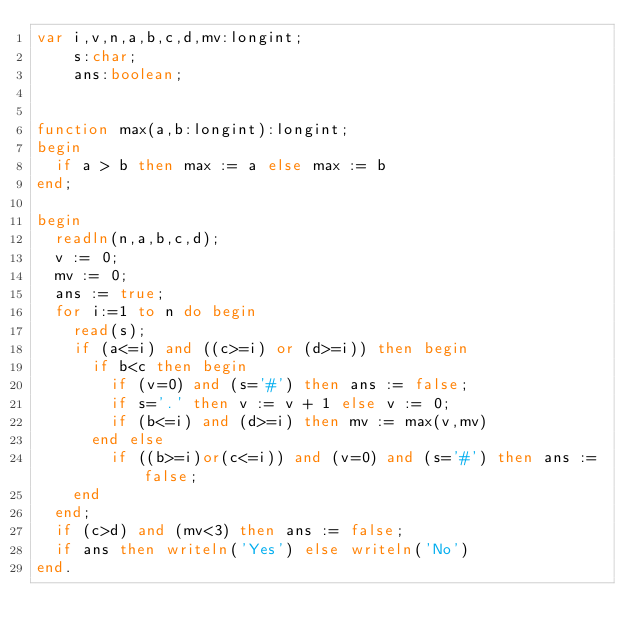Convert code to text. <code><loc_0><loc_0><loc_500><loc_500><_Pascal_>var i,v,n,a,b,c,d,mv:longint;
    s:char;
    ans:boolean;


function max(a,b:longint):longint;
begin
  if a > b then max := a else max := b
end;

begin
  readln(n,a,b,c,d);
  v := 0;
  mv := 0;
  ans := true;
  for i:=1 to n do begin
    read(s);
    if (a<=i) and ((c>=i) or (d>=i)) then begin
      if b<c then begin
        if (v=0) and (s='#') then ans := false;
        if s='.' then v := v + 1 else v := 0;
        if (b<=i) and (d>=i) then mv := max(v,mv)
      end else 
        if ((b>=i)or(c<=i)) and (v=0) and (s='#') then ans := false;
    end
  end;
  if (c>d) and (mv<3) then ans := false;
  if ans then writeln('Yes') else writeln('No')
end.</code> 